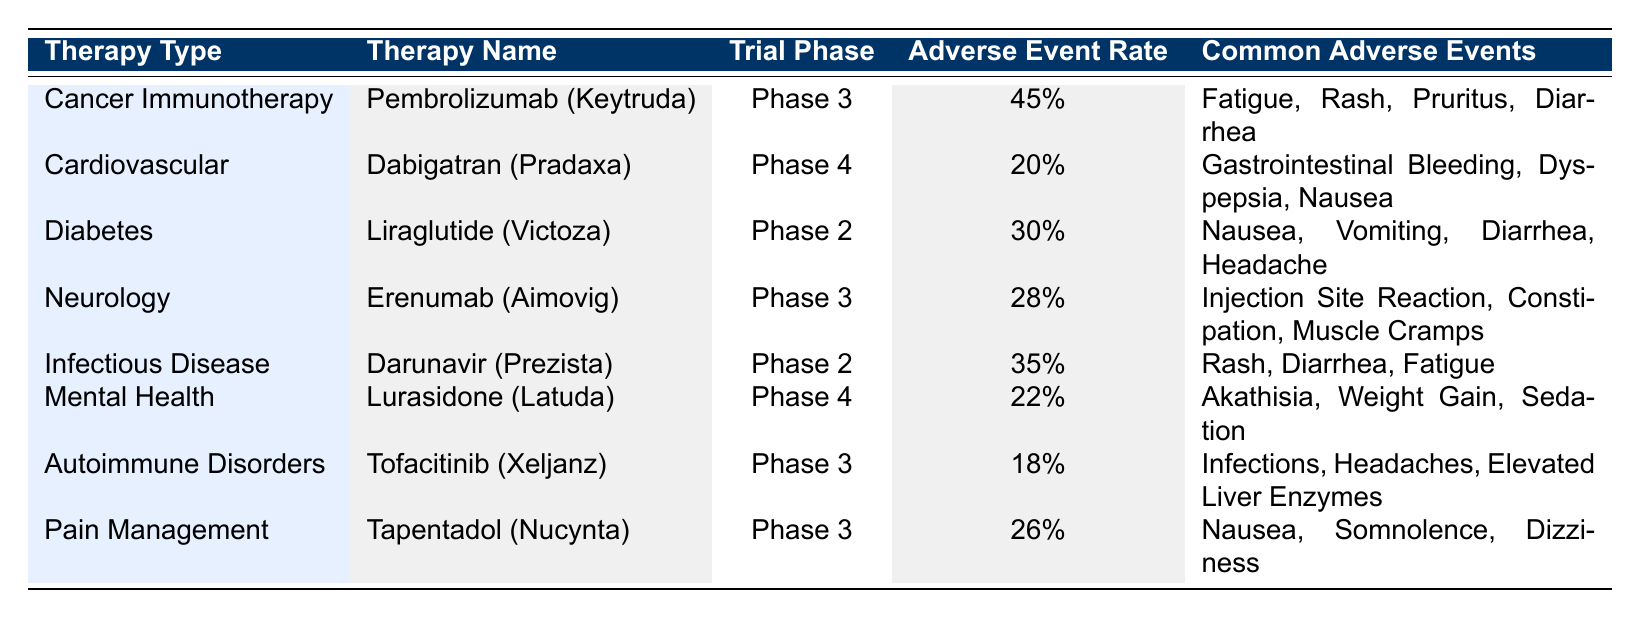What is the highest adverse event reporting rate among the therapies listed? The table shows the adverse event rates for each therapy type. By reviewing the adverse event rates, Pembrolizumab (Keytruda) has the highest rate at 45%.
Answer: 45% Which therapy has the lowest adverse event reporting rate? Looking through the adverse event rates in the table, Tofacitinib (Xeljanz) has the lowest reporting rate at 18%.
Answer: 18% Can you list the common adverse events associated with Lurasidone (Latuda)? The table indicates that for Lurasidone (Latuda), the common adverse events include Akathisia, Weight Gain, and Sedation.
Answer: Akathisia, Weight Gain, Sedation What is the average adverse event reporting rate for the therapies in the Neurology category? According to the table, there is one therapy listed under Neurology, Erenumab (Aimovig), with an adverse event rate of 28%. Since there's only one entry, the average is also 28%.
Answer: 28% Is the adverse event rate for Darunavir (Prezista) higher than the average rate for pain management therapies? The adverse event rate for Darunavir (Prezista) is 35%, and Tapentadol (Nucynta) has an adverse event rate of 26% under Pain Management. The average for pain management is 26%, thus Darunavir is higher.
Answer: Yes Which therapy type has the second highest reporting rate for adverse events? By examining the rates, the therapies listed with their rates are Cancer Immunotherapy (45%), Infectious Disease (35%), Diabetes (30%), Neurology (28%), Pain Management (26%), Mental Health (22%), Cardiovascular (20%), and Autoimmune Disorders (18%). After Cancer Immunotherapy, Infectious Disease holds the second position with 35%.
Answer: Infectious Disease Do any of the therapies listed have common adverse events that include 'Nausea'? The table indicates that both Liraglutide (Victoza) and Tapentadol (Nucynta) list 'Nausea' as a common adverse event.
Answer: Yes What is the total adverse event reporting rate of therapies in the Diabetes and Pain Management categories combined? The adverse event rate for Liraglutide (Victoza) in Diabetes is 30%, and for Tapentadol (Nucynta) in Pain Management is 26%. Adding these together gives 30 + 26 = 56%.
Answer: 56% 